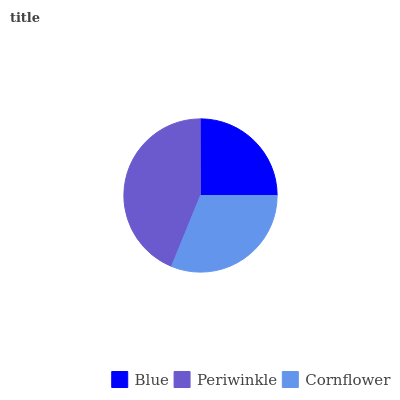Is Blue the minimum?
Answer yes or no. Yes. Is Periwinkle the maximum?
Answer yes or no. Yes. Is Cornflower the minimum?
Answer yes or no. No. Is Cornflower the maximum?
Answer yes or no. No. Is Periwinkle greater than Cornflower?
Answer yes or no. Yes. Is Cornflower less than Periwinkle?
Answer yes or no. Yes. Is Cornflower greater than Periwinkle?
Answer yes or no. No. Is Periwinkle less than Cornflower?
Answer yes or no. No. Is Cornflower the high median?
Answer yes or no. Yes. Is Cornflower the low median?
Answer yes or no. Yes. Is Periwinkle the high median?
Answer yes or no. No. Is Blue the low median?
Answer yes or no. No. 